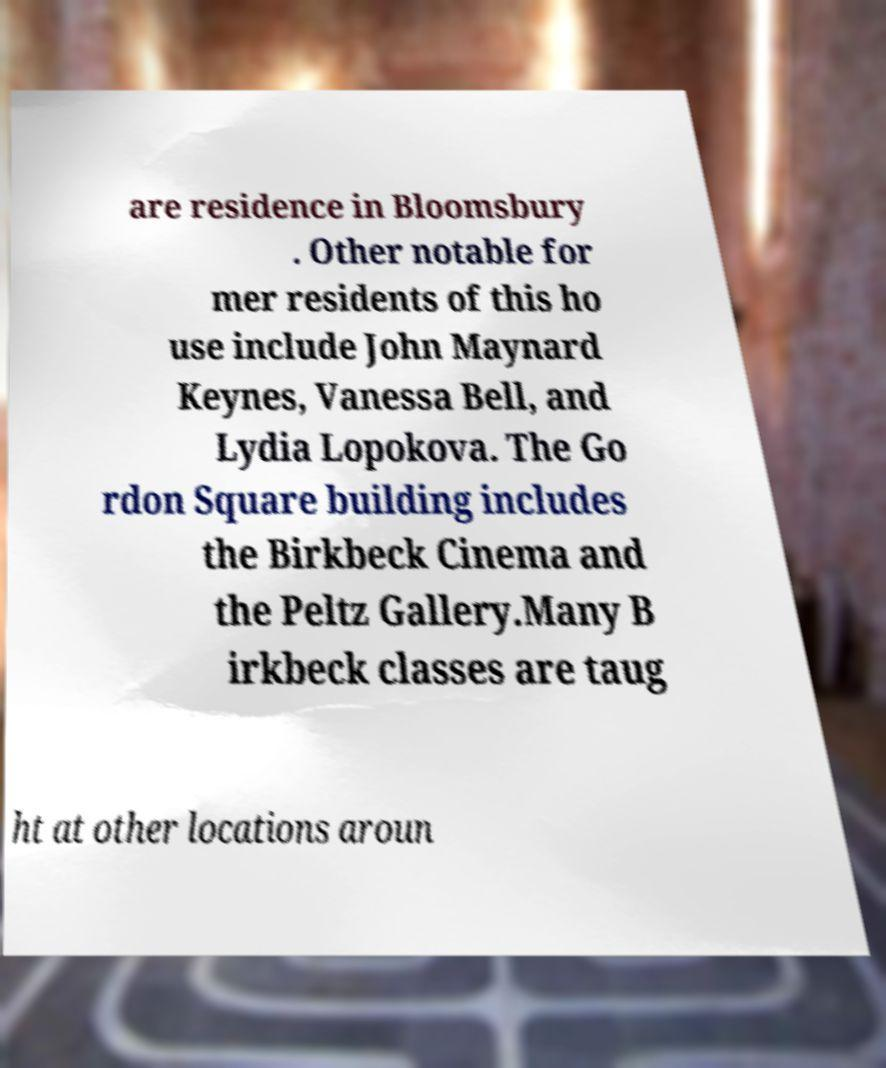Could you assist in decoding the text presented in this image and type it out clearly? are residence in Bloomsbury . Other notable for mer residents of this ho use include John Maynard Keynes, Vanessa Bell, and Lydia Lopokova. The Go rdon Square building includes the Birkbeck Cinema and the Peltz Gallery.Many B irkbeck classes are taug ht at other locations aroun 